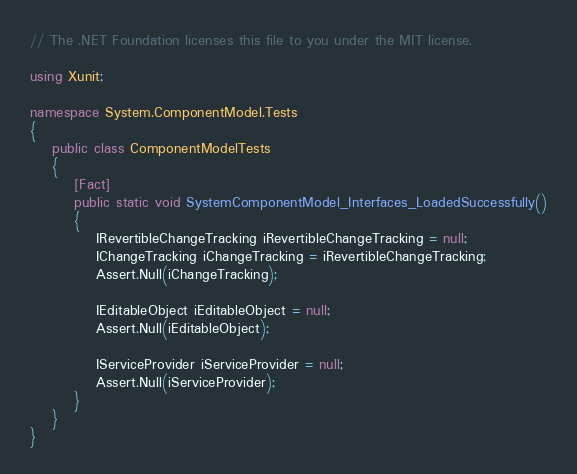Convert code to text. <code><loc_0><loc_0><loc_500><loc_500><_C#_>// The .NET Foundation licenses this file to you under the MIT license.

using Xunit;

namespace System.ComponentModel.Tests
{
    public class ComponentModelTests
    {
        [Fact]
        public static void SystemComponentModel_Interfaces_LoadedSuccessfully()
        {
            IRevertibleChangeTracking iRevertibleChangeTracking = null;
            IChangeTracking iChangeTracking = iRevertibleChangeTracking;
            Assert.Null(iChangeTracking);

            IEditableObject iEditableObject = null;
            Assert.Null(iEditableObject);

            IServiceProvider iServiceProvider = null;
            Assert.Null(iServiceProvider);
        }
    }
}
</code> 